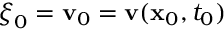Convert formula to latex. <formula><loc_0><loc_0><loc_500><loc_500>{ \boldsymbol \xi } _ { 0 } = { \mathbf v } _ { 0 } = { \mathbf v } ( { \mathbf x } _ { 0 } , t _ { 0 } )</formula> 